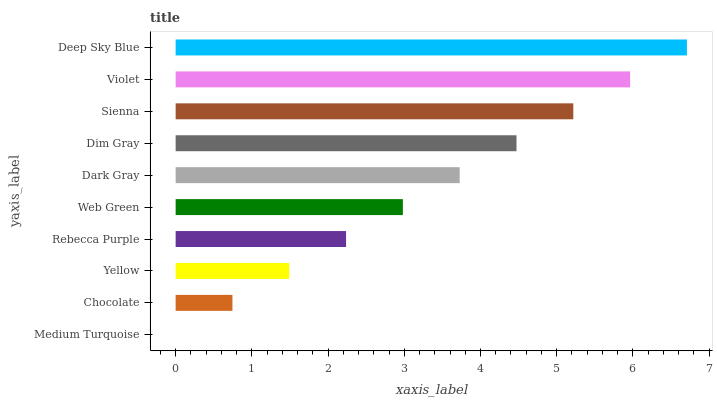Is Medium Turquoise the minimum?
Answer yes or no. Yes. Is Deep Sky Blue the maximum?
Answer yes or no. Yes. Is Chocolate the minimum?
Answer yes or no. No. Is Chocolate the maximum?
Answer yes or no. No. Is Chocolate greater than Medium Turquoise?
Answer yes or no. Yes. Is Medium Turquoise less than Chocolate?
Answer yes or no. Yes. Is Medium Turquoise greater than Chocolate?
Answer yes or no. No. Is Chocolate less than Medium Turquoise?
Answer yes or no. No. Is Dark Gray the high median?
Answer yes or no. Yes. Is Web Green the low median?
Answer yes or no. Yes. Is Medium Turquoise the high median?
Answer yes or no. No. Is Yellow the low median?
Answer yes or no. No. 